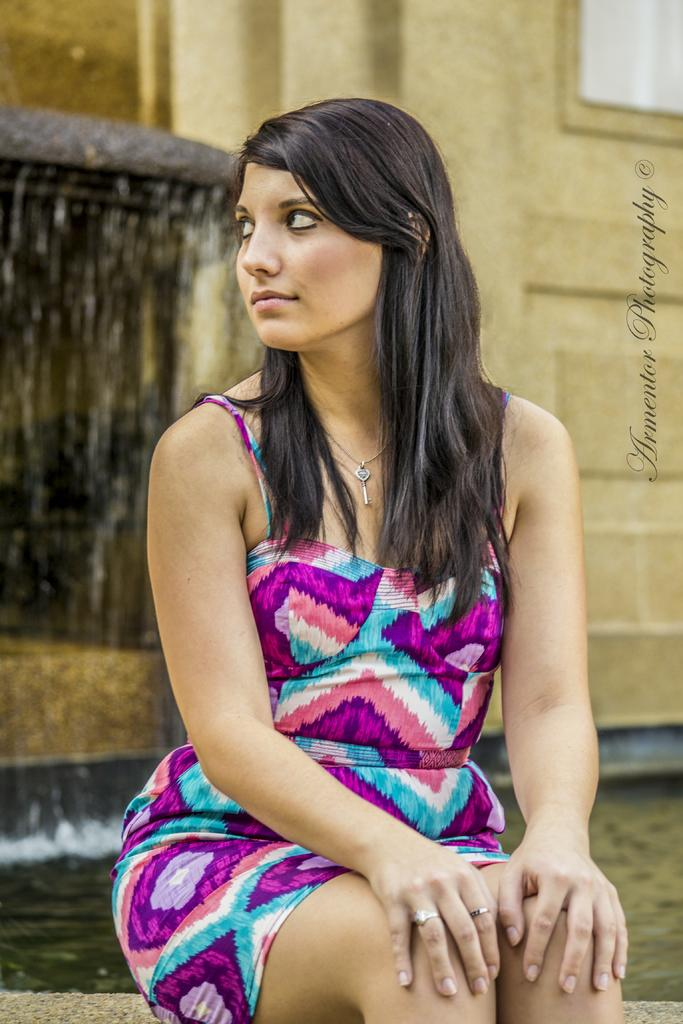What is the woman in the image doing? The woman is sitting in the image. What can be seen behind the woman? There is water visible behind the woman. What is located to the left of the woman? There is a water fountain to the left of the woman. What is situated to the right of the woman? There is a wall to the right of the woman. What is present to the right of the image? There is text to the right of the image. What type of bean is being used as a musical instrument in the image? There is no bean present in the image, let alone one being used as a musical instrument. 